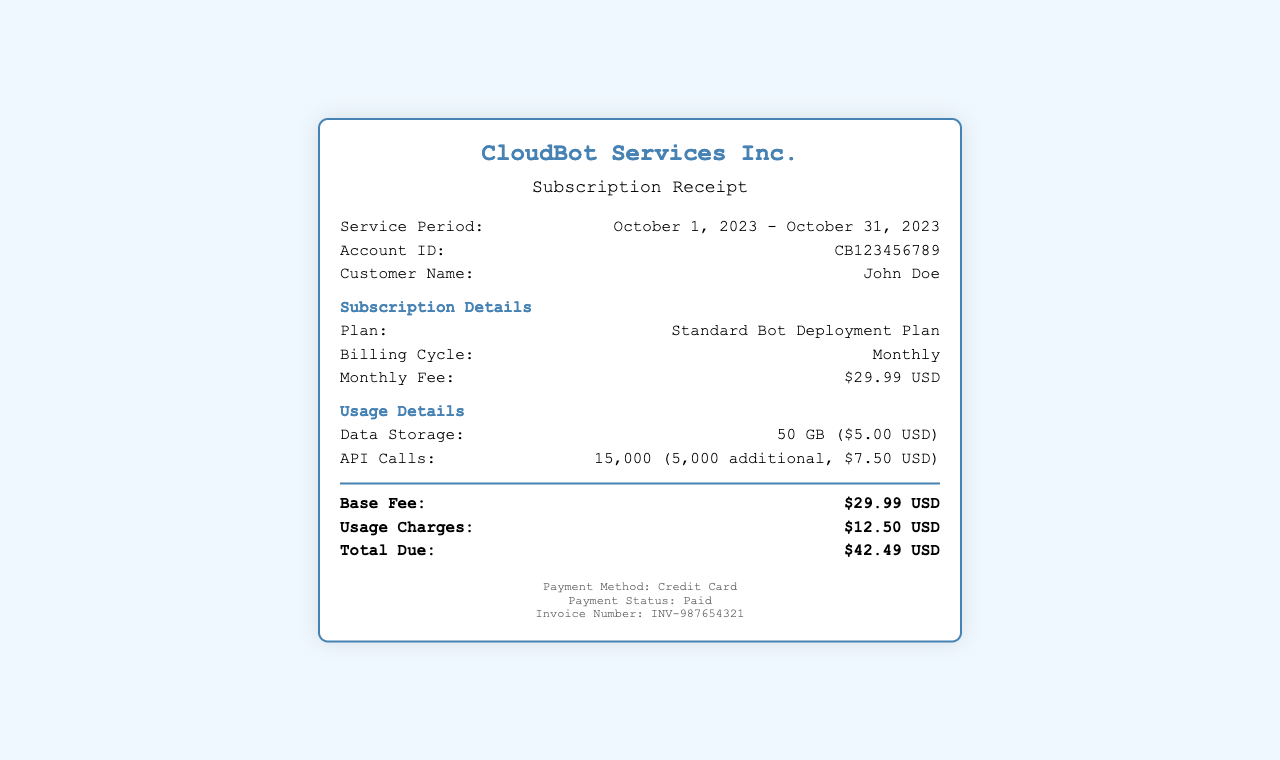What is the service period? The service period is indicated in the details section, spanning from October 1, 2023, to October 31, 2023.
Answer: October 1, 2023 - October 31, 2023 What is the account ID? The account ID can be found in the details section of the receipt, which is a unique identifier for the account.
Answer: CB123456789 Who is the customer? The customer's name is provided in the details section of the receipt.
Answer: John Doe What is the monthly fee? The monthly fee is explicitly stated in the Subscription Details section of the document.
Answer: $29.99 USD How much is the data storage charge? The data storage charge is detailed in the Usage Details section, indicating costs associated with data storage.
Answer: $5.00 USD How many API calls were made? The number of API calls is listed in the Usage Details section, which includes additional usage charges as well.
Answer: 15,000 What is the total due? The total due is calculated and displayed at the bottom of the totals section, summarizing all fees and charges.
Answer: $42.49 USD What payment method was used? The payment method is noted in the footer of the receipt, identifying how the payment was made.
Answer: Credit Card What is the invoice number? The invoice number is listed in the footer section, serving as a reference for the transaction.
Answer: INV-987654321 